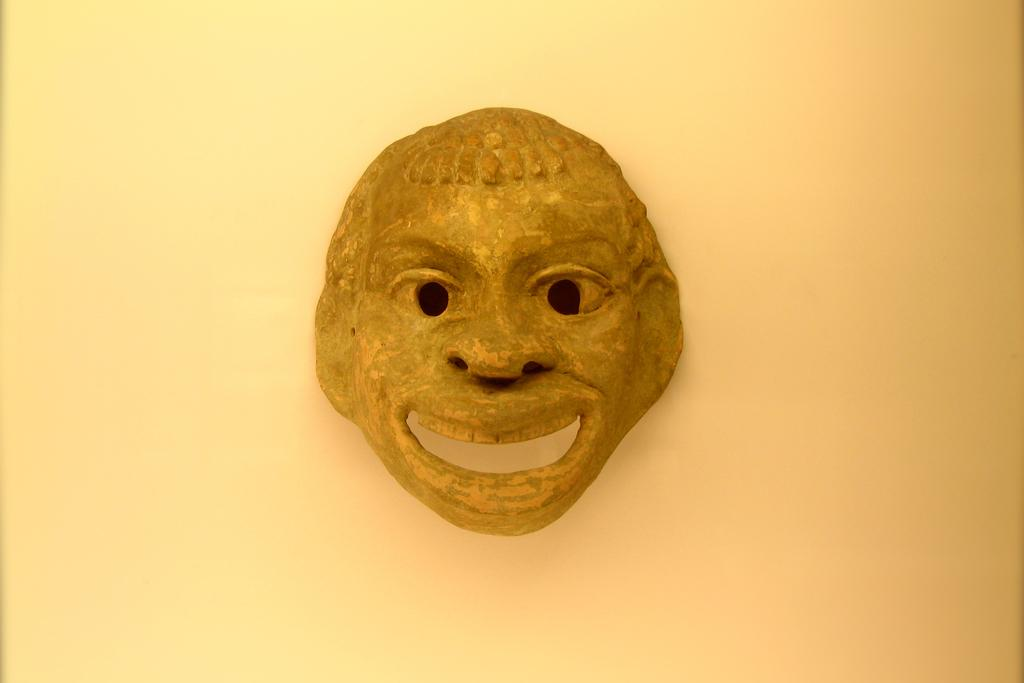What object is present in the image? There is a face mask in the image. What color is the face mask? The face mask is in dark yellow color. Where is the face mask located in the image? The face mask is placed on a surface. How many fire hydrants can be seen in the image? There are no fire hydrants present in the image. What is the cent of the face mask in the image? The concept of a "cent" does not apply to the face mask in the image, as it is a solid object and not a circular shape. 